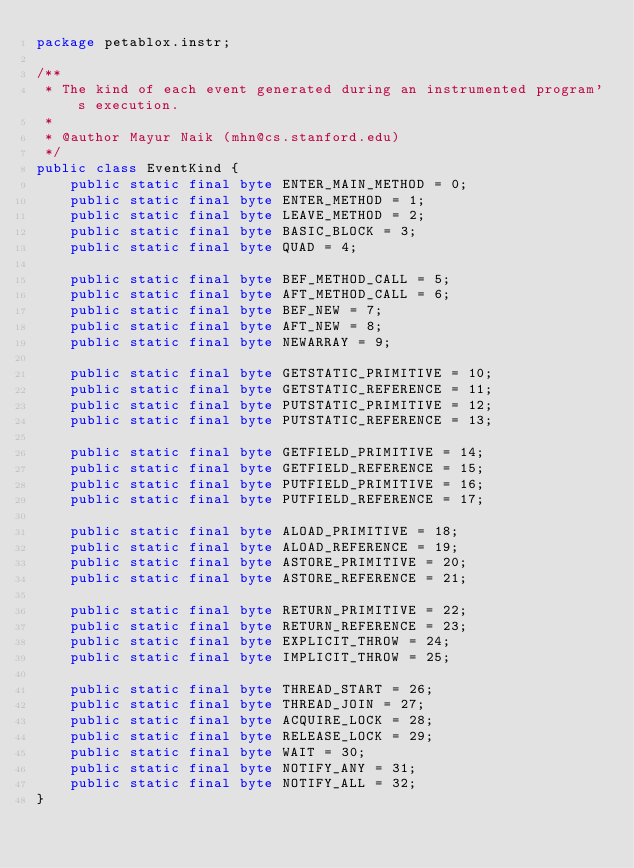<code> <loc_0><loc_0><loc_500><loc_500><_Java_>package petablox.instr;

/**
 * The kind of each event generated during an instrumented program's execution.
 * 
 * @author Mayur Naik (mhn@cs.stanford.edu)
 */
public class EventKind {
    public static final byte ENTER_MAIN_METHOD = 0;
    public static final byte ENTER_METHOD = 1;
    public static final byte LEAVE_METHOD = 2;
    public static final byte BASIC_BLOCK = 3;
    public static final byte QUAD = 4;

    public static final byte BEF_METHOD_CALL = 5;
    public static final byte AFT_METHOD_CALL = 6;
    public static final byte BEF_NEW = 7;
    public static final byte AFT_NEW = 8;
    public static final byte NEWARRAY = 9;

    public static final byte GETSTATIC_PRIMITIVE = 10;
    public static final byte GETSTATIC_REFERENCE = 11;
    public static final byte PUTSTATIC_PRIMITIVE = 12;
    public static final byte PUTSTATIC_REFERENCE = 13;

    public static final byte GETFIELD_PRIMITIVE = 14;
    public static final byte GETFIELD_REFERENCE = 15;
    public static final byte PUTFIELD_PRIMITIVE = 16;
    public static final byte PUTFIELD_REFERENCE = 17;

    public static final byte ALOAD_PRIMITIVE = 18;
    public static final byte ALOAD_REFERENCE = 19;
    public static final byte ASTORE_PRIMITIVE = 20; 
    public static final byte ASTORE_REFERENCE = 21; 

    public static final byte RETURN_PRIMITIVE = 22;
    public static final byte RETURN_REFERENCE = 23;
    public static final byte EXPLICIT_THROW = 24;
    public static final byte IMPLICIT_THROW = 25;

    public static final byte THREAD_START = 26;
    public static final byte THREAD_JOIN = 27;
    public static final byte ACQUIRE_LOCK = 28;
    public static final byte RELEASE_LOCK = 29;
    public static final byte WAIT = 30;
    public static final byte NOTIFY_ANY = 31;
    public static final byte NOTIFY_ALL = 32;
}
</code> 